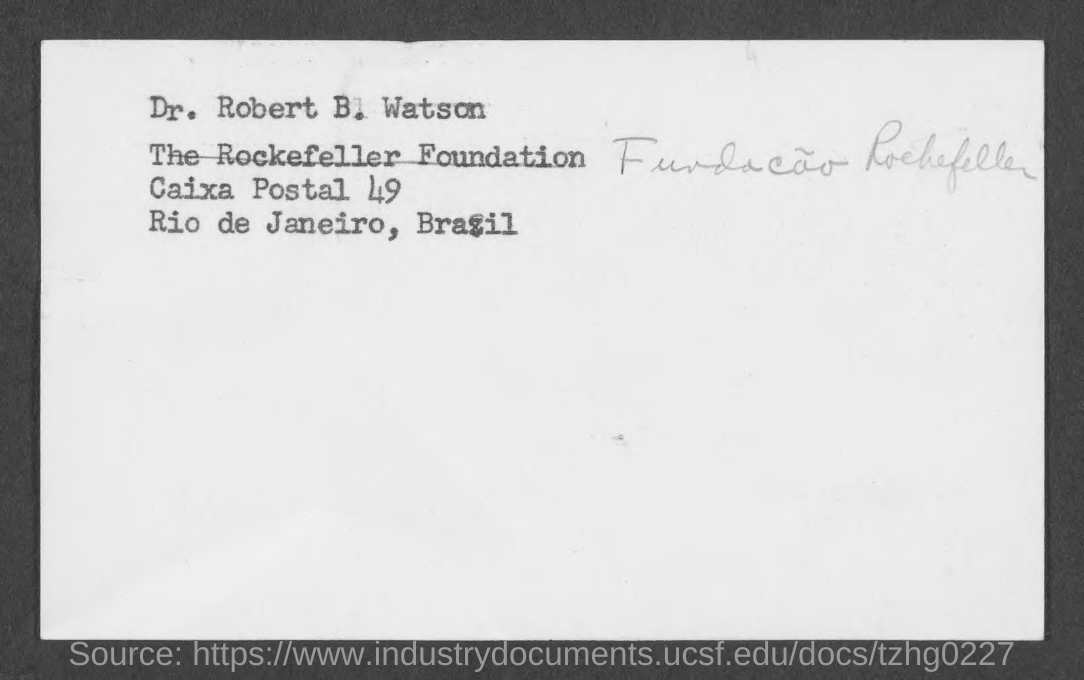Whose address is given?
Provide a succinct answer. Dr. Robert B. Watson. What is the POSTAL number mentioned?
Ensure brevity in your answer.  49. "Dr. Robert B. Watson" belongs to which country?
Your response must be concise. Brazil. 